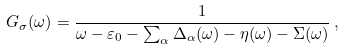<formula> <loc_0><loc_0><loc_500><loc_500>G _ { \sigma } ( \omega ) = \frac { 1 } { \omega - \varepsilon _ { 0 } - \sum _ { \alpha } \Delta _ { \alpha } ( \omega ) - \eta ( \omega ) - \Sigma ( \omega ) } \, ,</formula> 